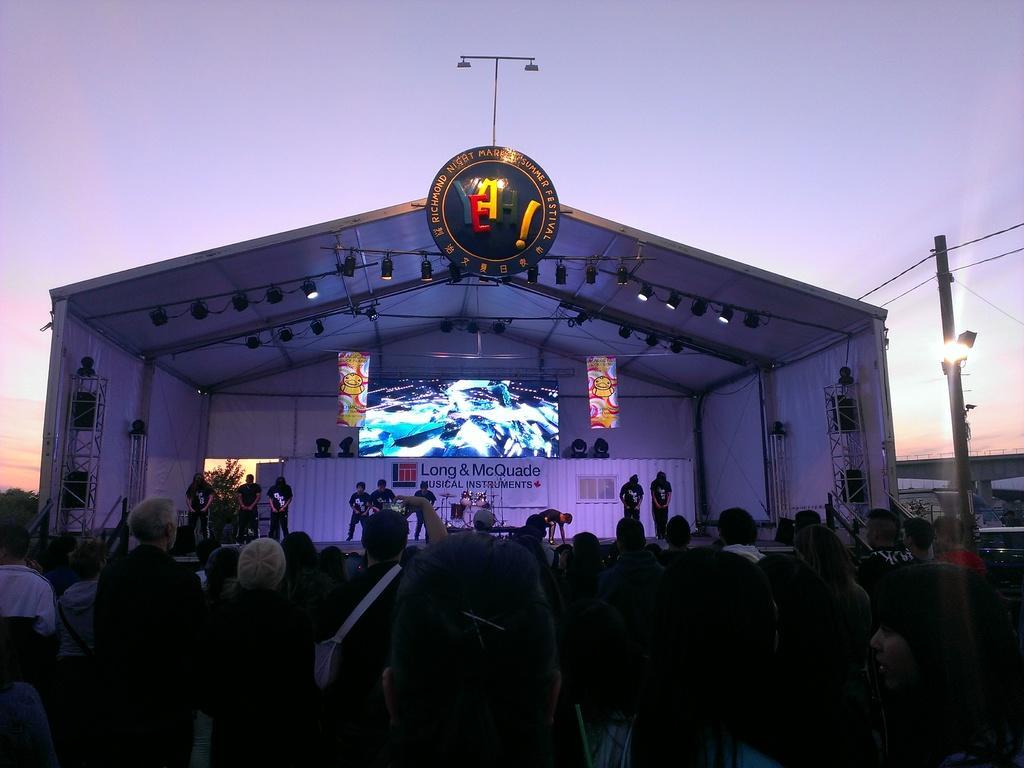In one or two sentences, can you explain what this image depicts? This picture describes about group of people, few people are holding mobiles in their hands, in front of them we can find few metal rods, speakers, musical instruments and few musicians on the stage, and also we can find a shed, lights and a pole. 